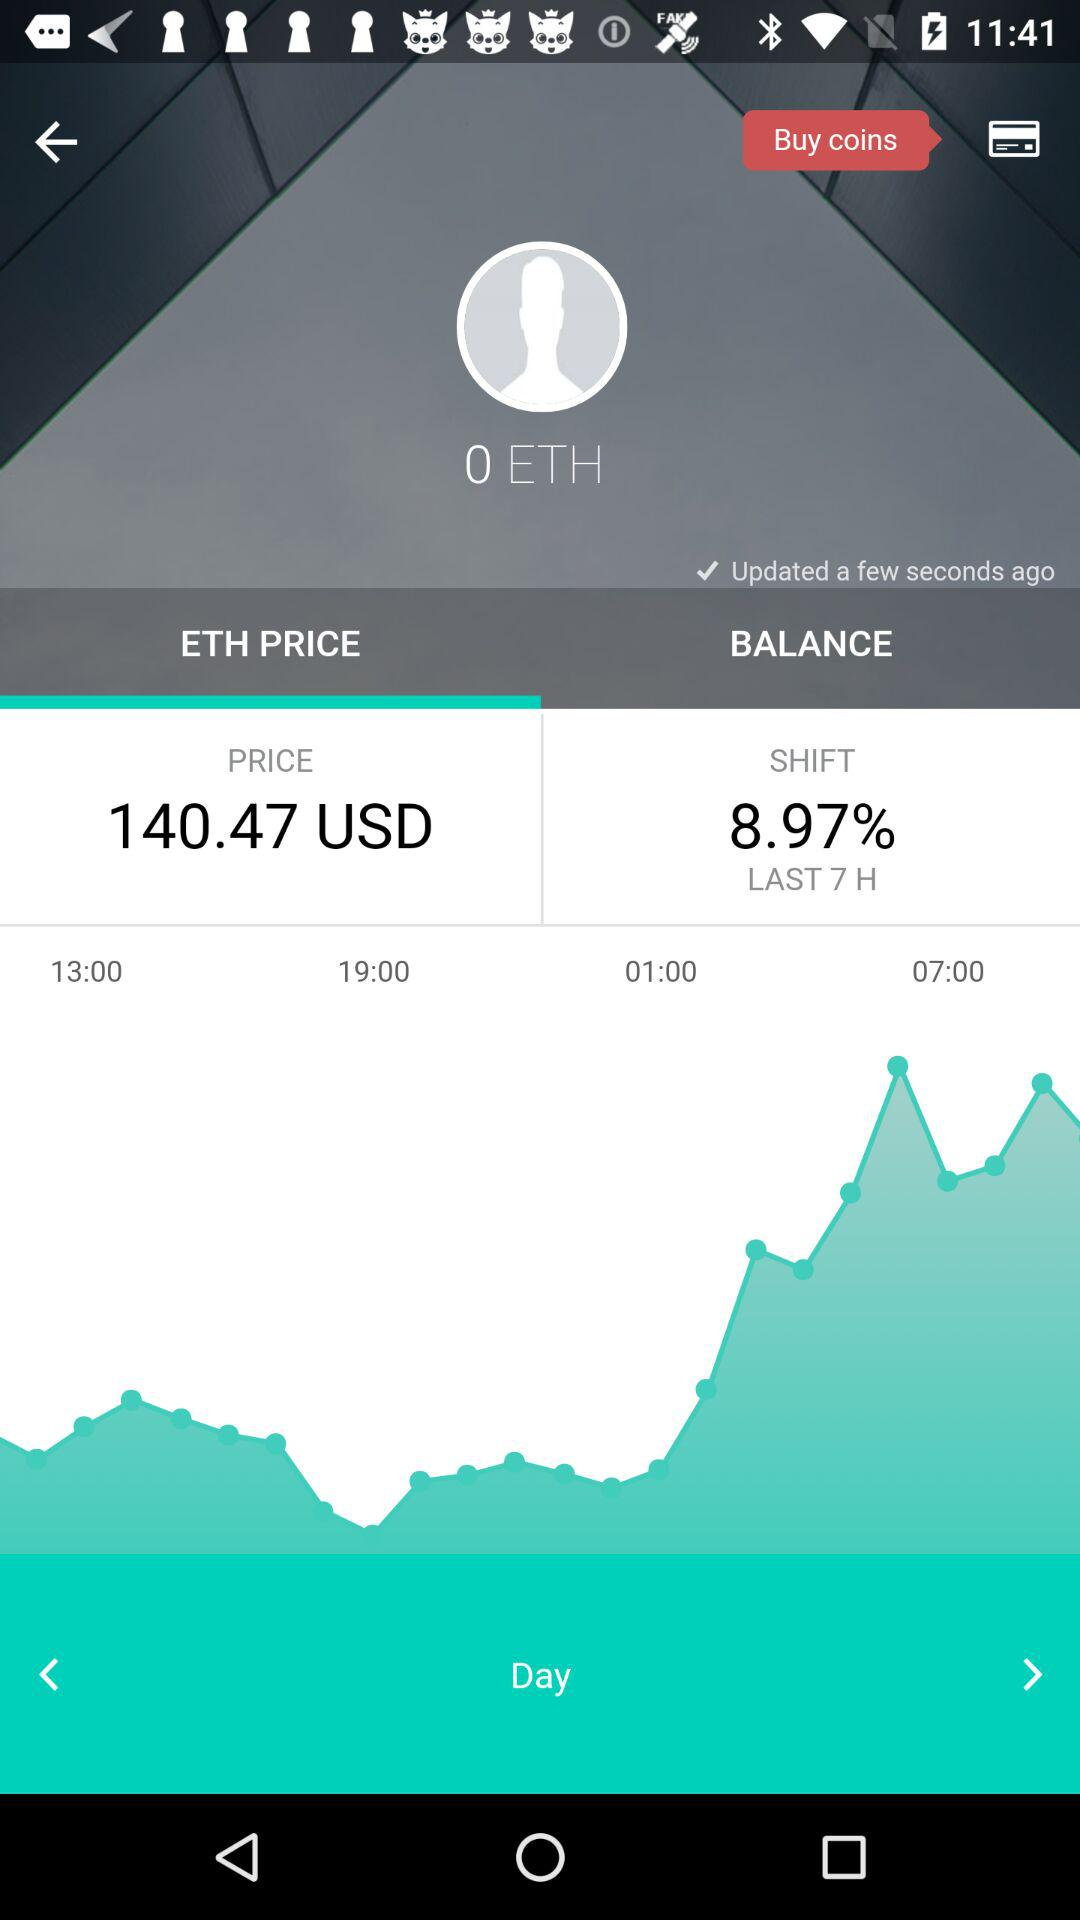When was the shift percentage calculated? The shift percentage was calculated in the last 7 hours. 